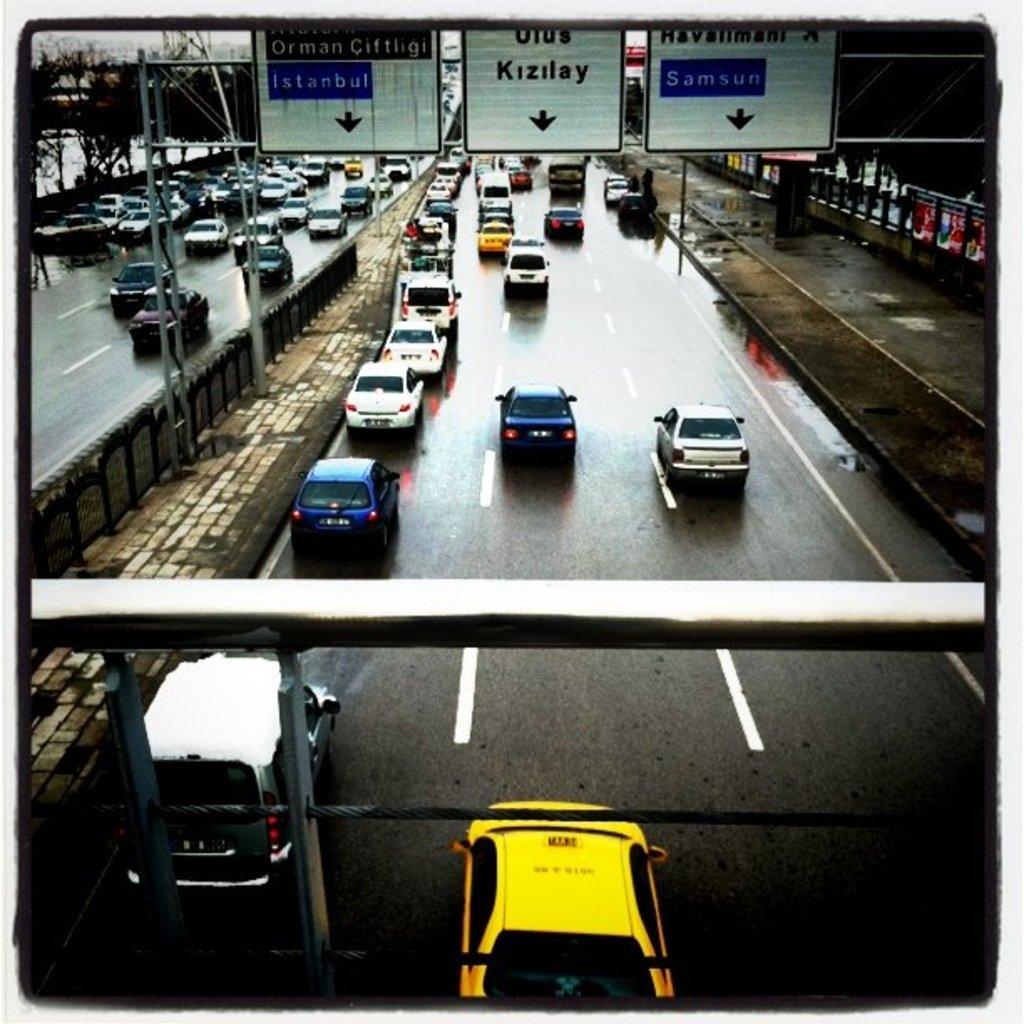What's one of the words on the road signs?
Keep it short and to the point. Kizilay. The middle sign takes you to?
Give a very brief answer. Kizilay. 